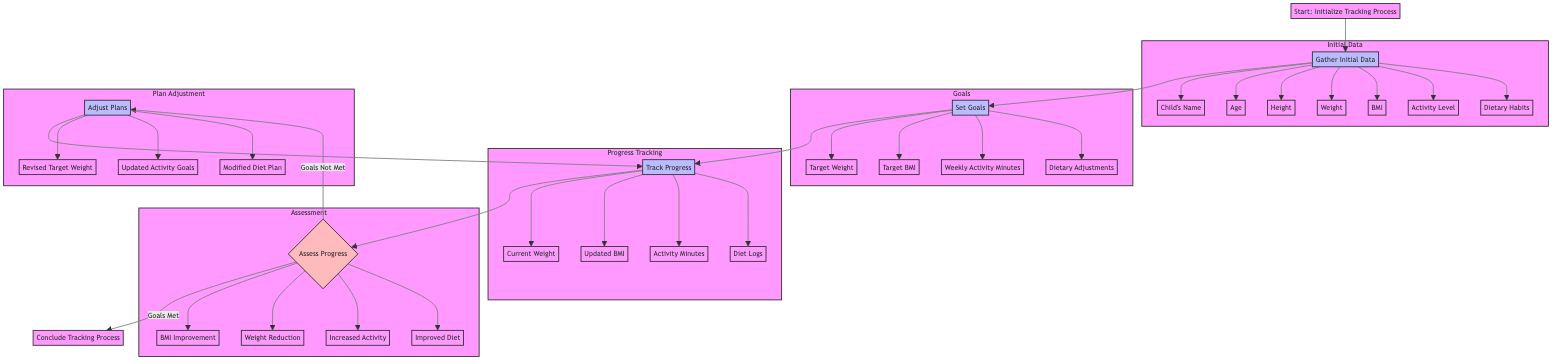What is the first step in the process? The first step is labeled as "Initialize Tracking Process." It is indicated at the beginning of the flowchart, before any other actions.
Answer: Initialize Tracking Process How many elements are there in the assessment criteria? The assessment criteria include four elements: BMI Improvement, Weight Reduction, Increased Physical Activity, and Improved Dietary Habits. Each of these is listed under the assessment node in the diagram.
Answer: 4 What action follows the "Set Goals" step? Following "Set Goals," the next action is "Track Progress." This is a direct transition from one process to another according to the flow of the diagram.
Answer: Track Progress What happens if the goals are not met? If the goals are not met, the diagram indicates that the process leads to "Adjust Plans." This is shown as a decision point that determines the next step.
Answer: Adjust Plans What are the data fields collected in the "Gather Initial Data" stage? The data fields include Child's Name, Age, Height, Weight, Body Mass Index (BMI), Daily Activity Level, and Dietary Habits, as represented in the subgraph connected to the initial data collection process.
Answer: Child's Name, Age, Height, Weight, BMI, Activity Level, Dietary Habits How many nodes are there in the "Plan Adjustment" subgraph? The "Plan Adjustment" subgraph contains three nodes: Revised Target Weight, Updated Activity Goals, and Modified Diet Plan, which represent the potential adjustments based on prior progress assessments.
Answer: 3 What should be updated in the "Track Progress" phase? In the "Track Progress" phase, the items to be updated include Current Weight, Updated BMI, Activity Minutes, and Diet Logs. These are specifically listed under the progress tracking node.
Answer: Current Weight, Updated BMI, Activity Minutes, Diet Logs What is the outcome if goals are met? The outcome if goals are met is to "Conclude Tracking Process." The flowchart shows this as the terminal step following the assessment of progress.
Answer: Conclude Tracking Process What is the frequency of progress updates? The frequency of progress updates is specified as "Weekly" in the diagram, indicating how often the tracking should occur.
Answer: Weekly 